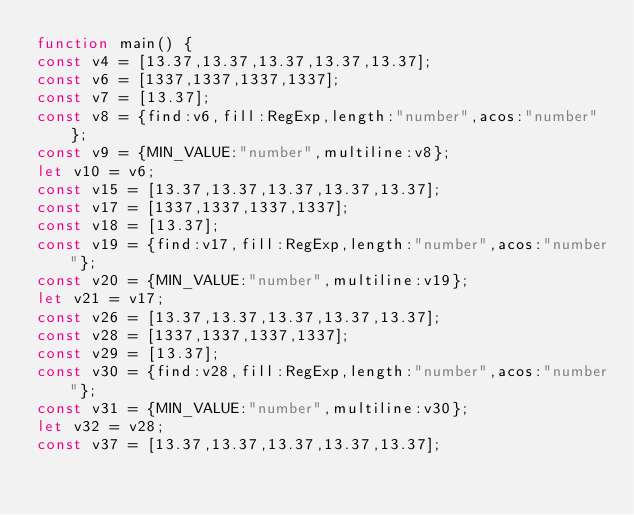<code> <loc_0><loc_0><loc_500><loc_500><_JavaScript_>function main() {
const v4 = [13.37,13.37,13.37,13.37,13.37];
const v6 = [1337,1337,1337,1337];
const v7 = [13.37];
const v8 = {find:v6,fill:RegExp,length:"number",acos:"number"};
const v9 = {MIN_VALUE:"number",multiline:v8};
let v10 = v6;
const v15 = [13.37,13.37,13.37,13.37,13.37];
const v17 = [1337,1337,1337,1337];
const v18 = [13.37];
const v19 = {find:v17,fill:RegExp,length:"number",acos:"number"};
const v20 = {MIN_VALUE:"number",multiline:v19};
let v21 = v17;
const v26 = [13.37,13.37,13.37,13.37,13.37];
const v28 = [1337,1337,1337,1337];
const v29 = [13.37];
const v30 = {find:v28,fill:RegExp,length:"number",acos:"number"};
const v31 = {MIN_VALUE:"number",multiline:v30};
let v32 = v28;
const v37 = [13.37,13.37,13.37,13.37,13.37];</code> 